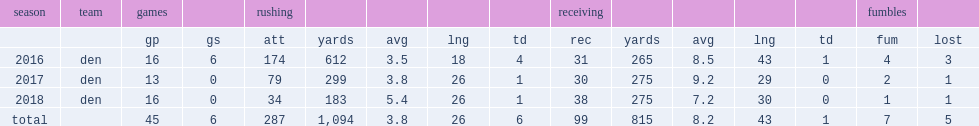How many rushing yards did booker get in 2016? 612.0. 